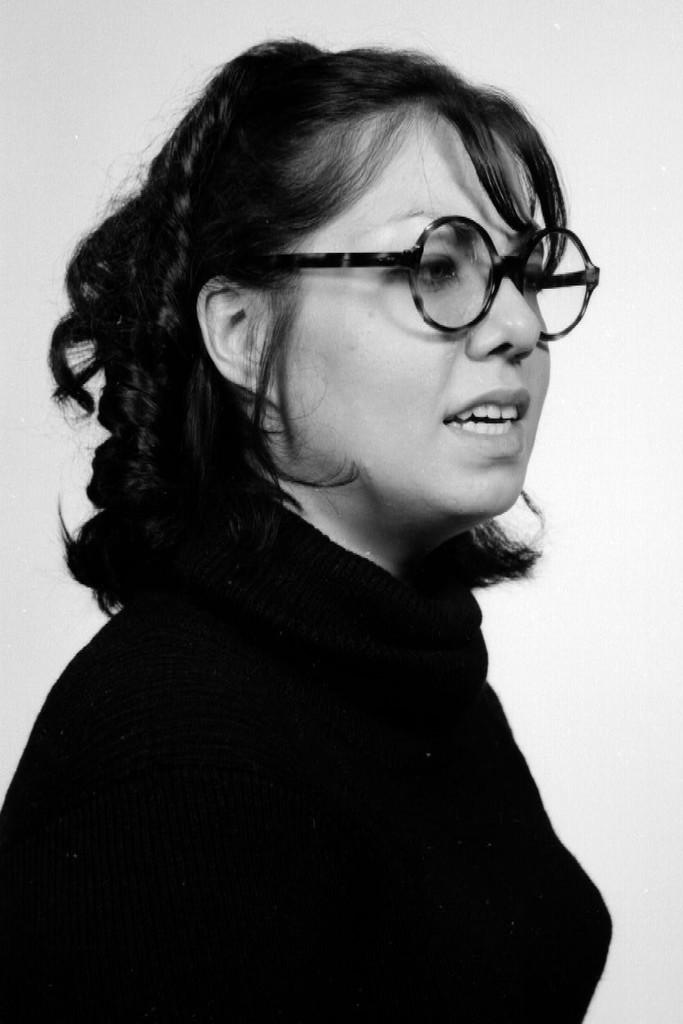Who is the main subject in the image? There is a woman in the image. Where is the woman positioned in the image? The woman is standing in the center of the image. What is the woman wearing in the image? The woman is wearing a black dress. What type of frame is the woman holding in the image? There is no frame present in the image; the woman is not holding anything. 